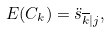Convert formula to latex. <formula><loc_0><loc_0><loc_500><loc_500>E ( C _ { k } ) = { \ddot { s } } _ { \overline { k } | j } ,</formula> 